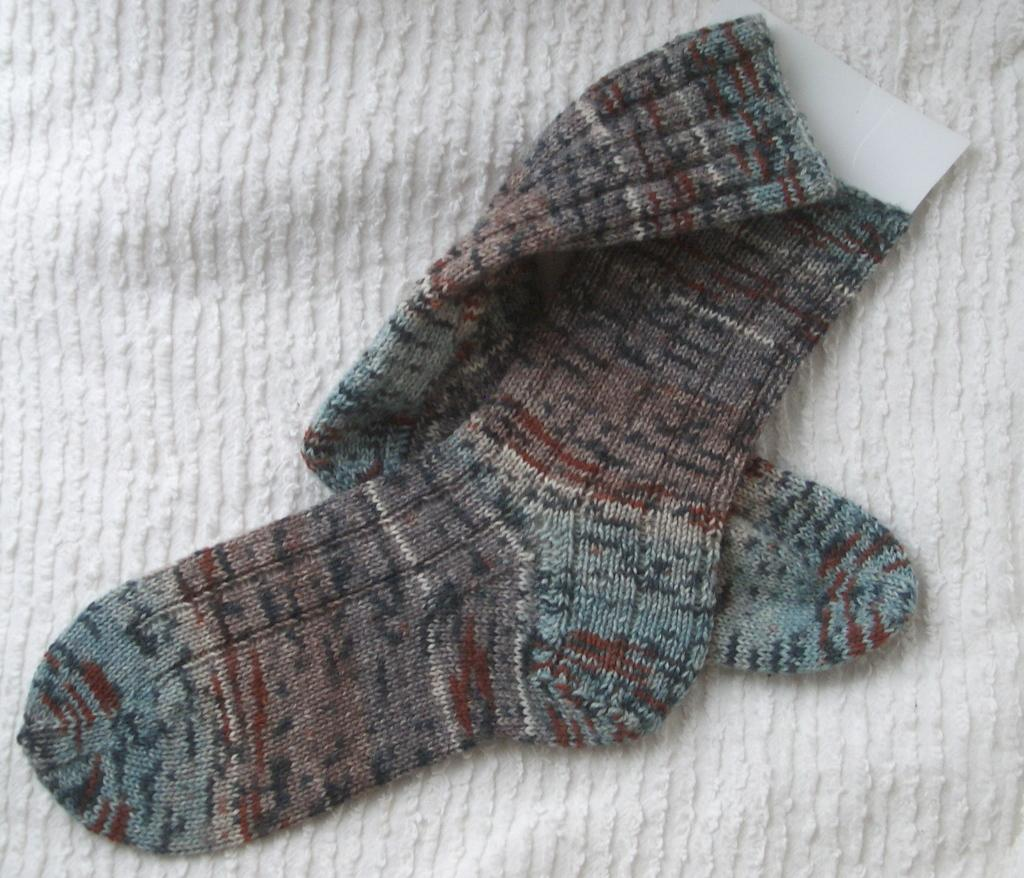What type of clothing items are in the image? There are socks in the image. What color is the cloth in the image? The cloth in the image is white. What type of wilderness can be seen in the image? There is no wilderness present in the image; it features socks and a white cloth. What type of metal is used to create the socks in the image? The socks in the image are made of fabric, not metal, so it is not possible to determine the type of metal used. 